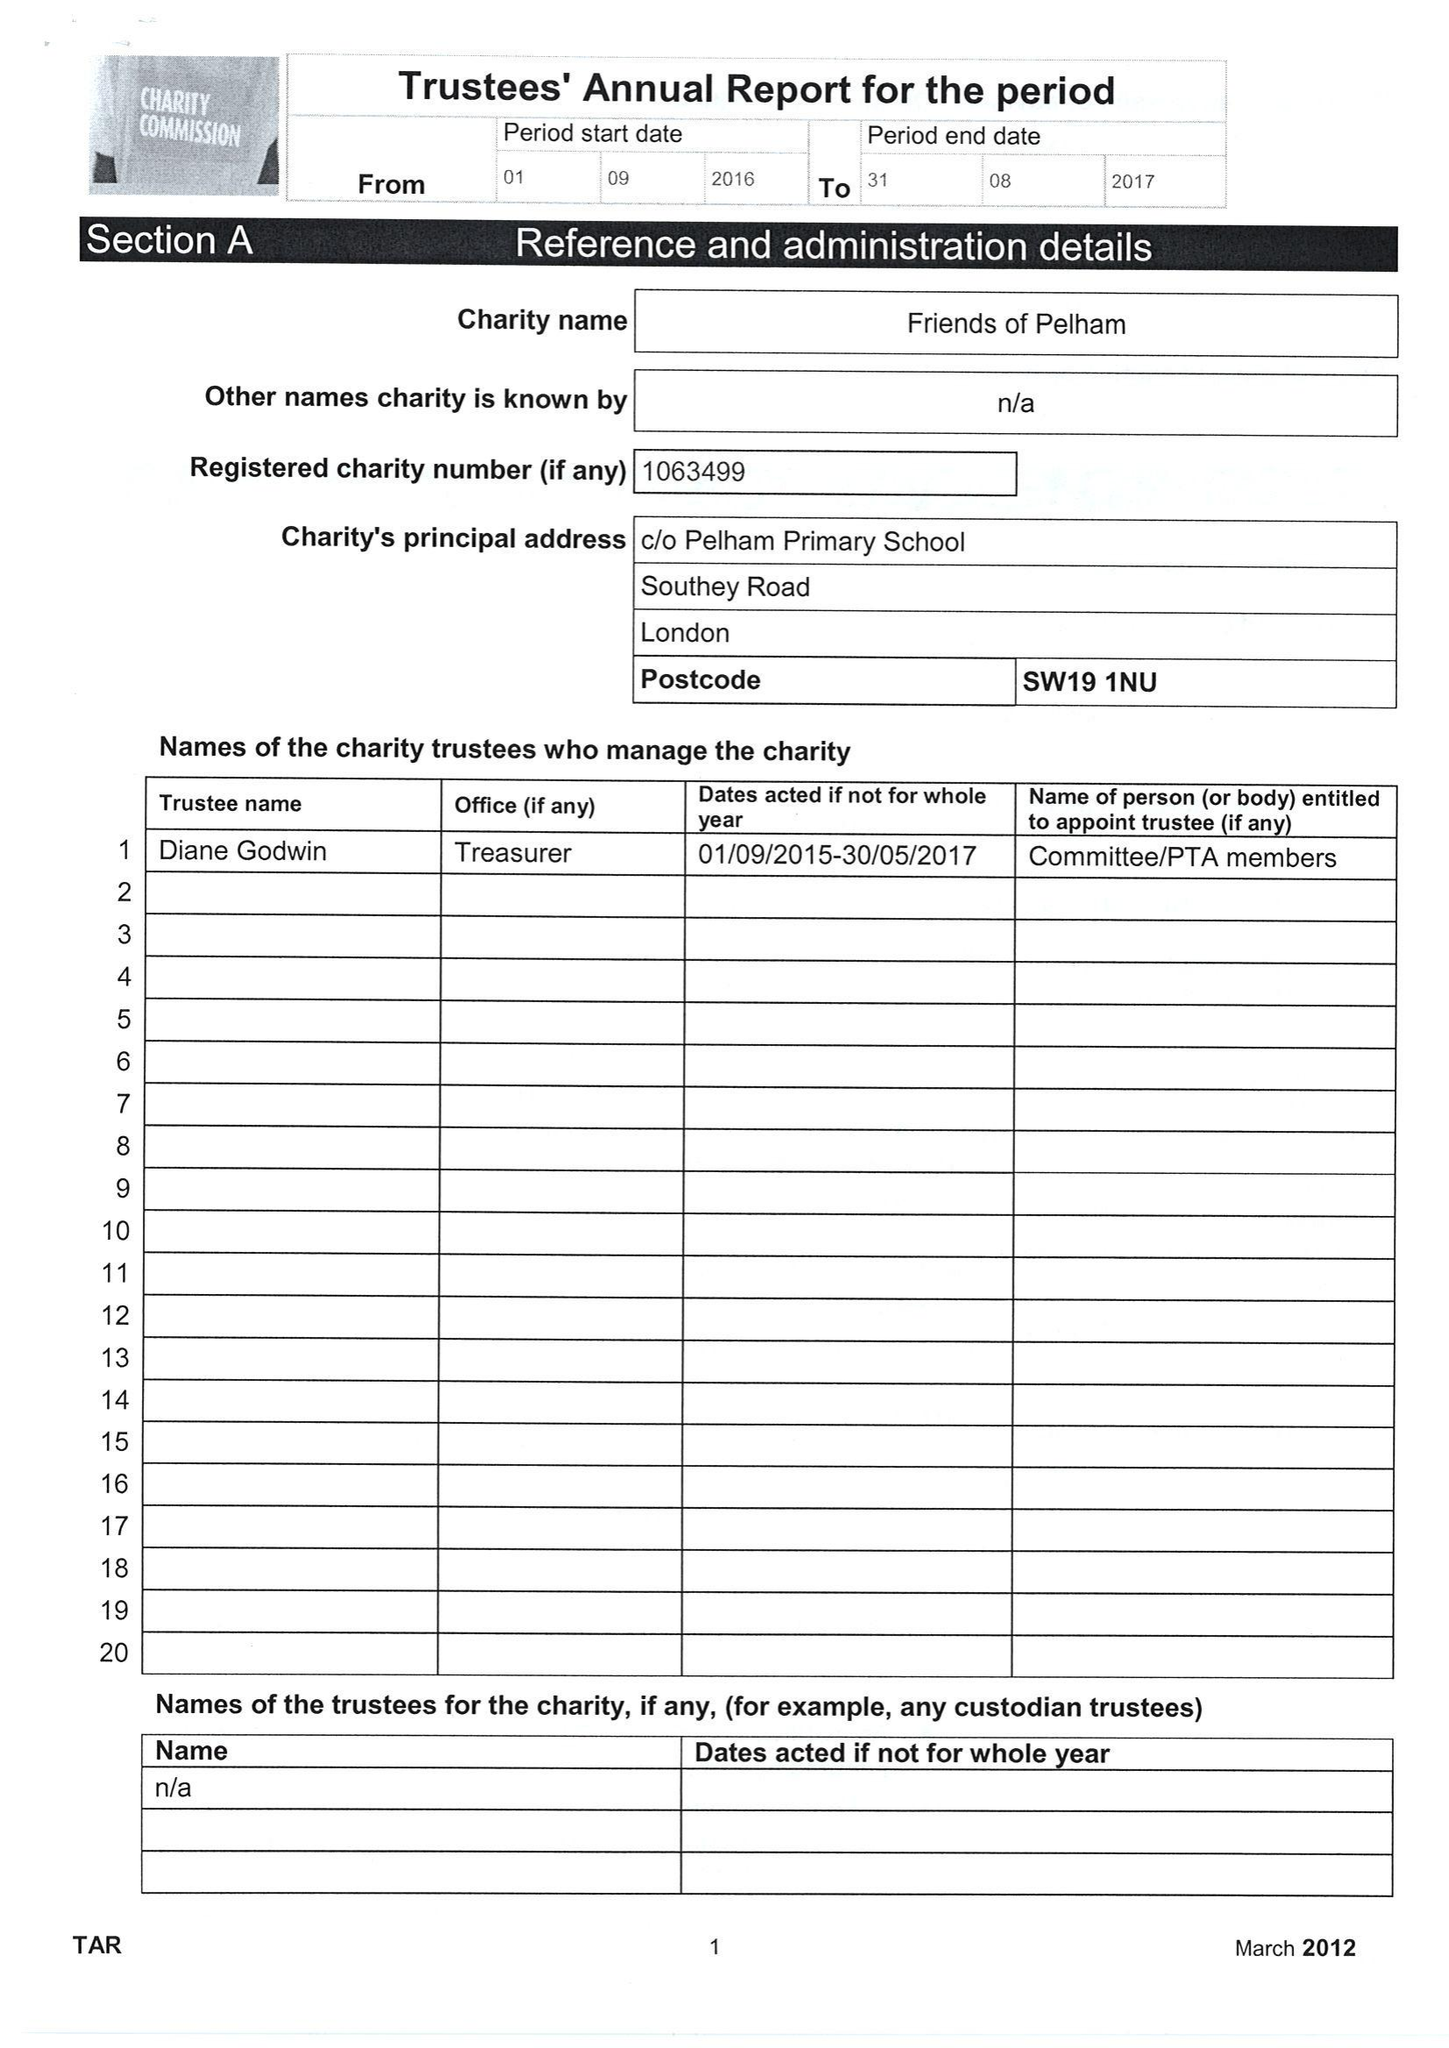What is the value for the spending_annually_in_british_pounds?
Answer the question using a single word or phrase. 27890.00 